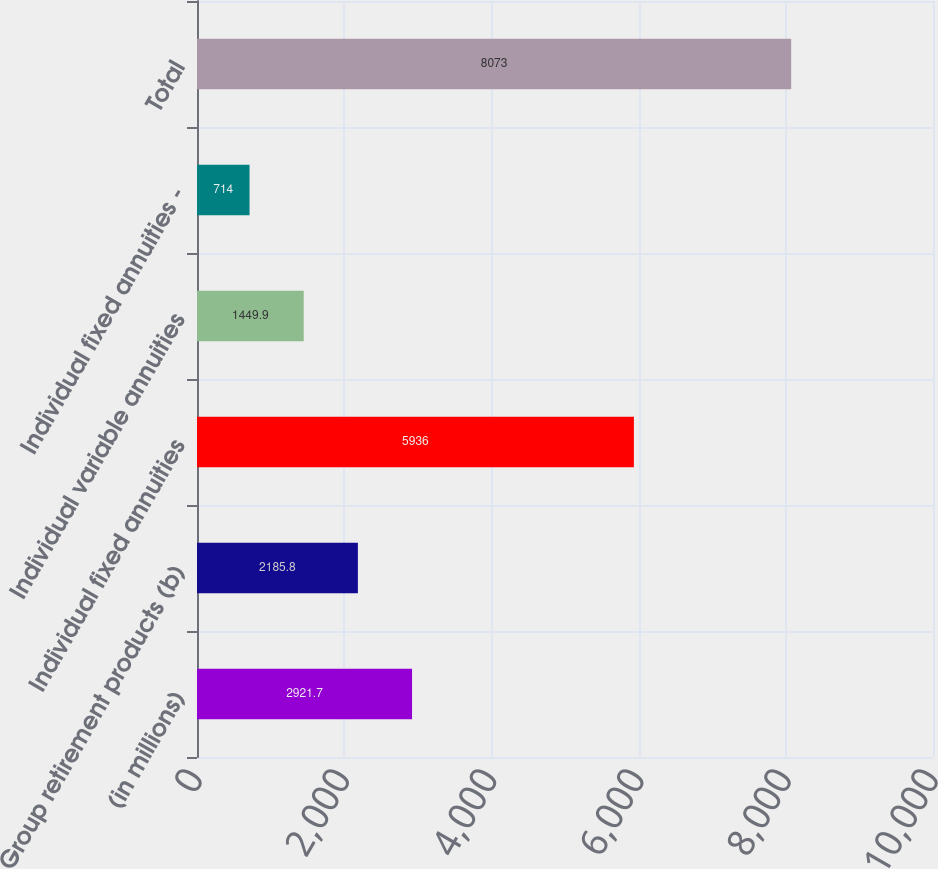Convert chart to OTSL. <chart><loc_0><loc_0><loc_500><loc_500><bar_chart><fcel>(in millions)<fcel>Group retirement products (b)<fcel>Individual fixed annuities<fcel>Individual variable annuities<fcel>Individual fixed annuities -<fcel>Total<nl><fcel>2921.7<fcel>2185.8<fcel>5936<fcel>1449.9<fcel>714<fcel>8073<nl></chart> 